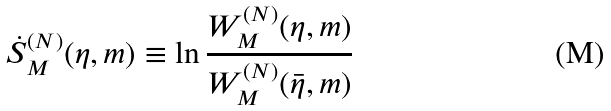Convert formula to latex. <formula><loc_0><loc_0><loc_500><loc_500>\dot { S } _ { M } ^ { ( N ) } ( \eta , m ) \equiv \ln \frac { W _ { M } ^ { ( N ) } ( \eta , m ) } { W _ { M } ^ { ( N ) } ( \bar { \eta } , m ) }</formula> 